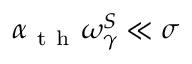Convert formula to latex. <formula><loc_0><loc_0><loc_500><loc_500>\alpha _ { t h } \omega _ { \gamma } ^ { S } \ll \sigma</formula> 